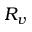Convert formula to latex. <formula><loc_0><loc_0><loc_500><loc_500>R _ { v }</formula> 